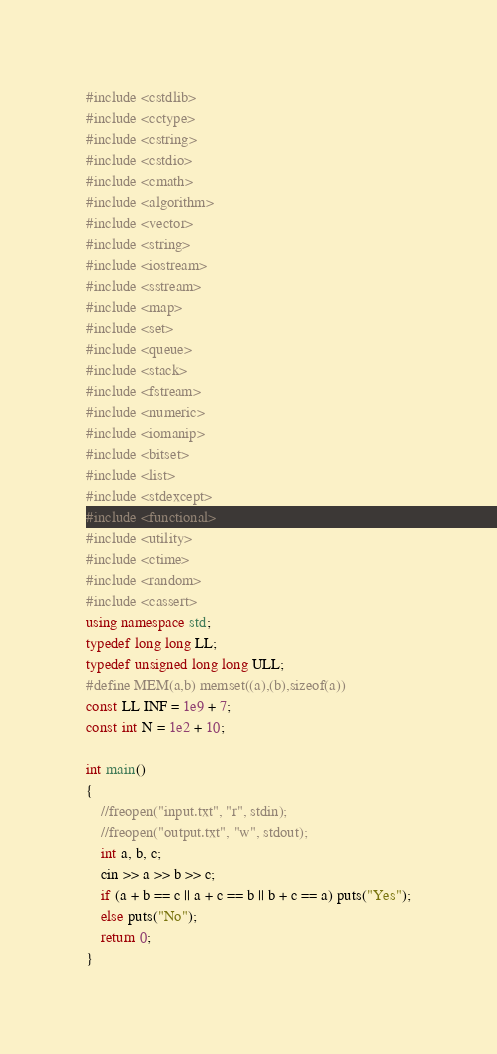<code> <loc_0><loc_0><loc_500><loc_500><_C++_>#include <cstdlib>
#include <cctype>
#include <cstring>
#include <cstdio>
#include <cmath>
#include <algorithm>
#include <vector>
#include <string>
#include <iostream>
#include <sstream>
#include <map>
#include <set>
#include <queue>
#include <stack>
#include <fstream>
#include <numeric>
#include <iomanip>
#include <bitset>
#include <list>
#include <stdexcept>
#include <functional>
#include <utility>
#include <ctime>
#include <random>
#include <cassert>
using namespace std;
typedef long long LL;
typedef unsigned long long ULL;
#define MEM(a,b) memset((a),(b),sizeof(a))
const LL INF = 1e9 + 7;
const int N = 1e2 + 10;

int main()
{
	//freopen("input.txt", "r", stdin);
	//freopen("output.txt", "w", stdout);
	int a, b, c;
	cin >> a >> b >> c;
	if (a + b == c || a + c == b || b + c == a) puts("Yes");
	else puts("No");
	return 0;
}</code> 